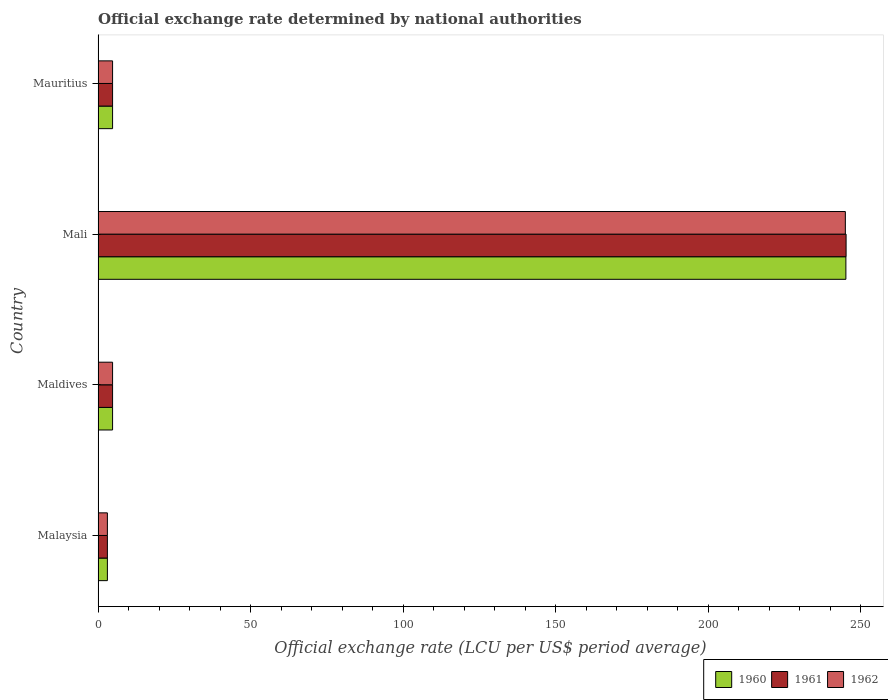How many different coloured bars are there?
Give a very brief answer. 3. How many groups of bars are there?
Keep it short and to the point. 4. Are the number of bars per tick equal to the number of legend labels?
Provide a succinct answer. Yes. How many bars are there on the 1st tick from the top?
Your answer should be very brief. 3. What is the label of the 2nd group of bars from the top?
Give a very brief answer. Mali. What is the official exchange rate in 1960 in Maldives?
Your response must be concise. 4.76. Across all countries, what is the maximum official exchange rate in 1961?
Keep it short and to the point. 245.26. Across all countries, what is the minimum official exchange rate in 1962?
Your response must be concise. 3.06. In which country was the official exchange rate in 1962 maximum?
Keep it short and to the point. Mali. In which country was the official exchange rate in 1960 minimum?
Keep it short and to the point. Malaysia. What is the total official exchange rate in 1960 in the graph?
Offer a very short reply. 257.78. What is the difference between the official exchange rate in 1961 in Mali and that in Mauritius?
Provide a succinct answer. 240.5. What is the difference between the official exchange rate in 1962 in Mauritius and the official exchange rate in 1960 in Maldives?
Your response must be concise. 0. What is the average official exchange rate in 1960 per country?
Offer a very short reply. 64.45. What is the difference between the official exchange rate in 1962 and official exchange rate in 1960 in Malaysia?
Provide a succinct answer. 0. What is the difference between the highest and the second highest official exchange rate in 1961?
Your response must be concise. 240.5. What is the difference between the highest and the lowest official exchange rate in 1962?
Give a very brief answer. 241.95. In how many countries, is the official exchange rate in 1962 greater than the average official exchange rate in 1962 taken over all countries?
Your response must be concise. 1. Is the sum of the official exchange rate in 1961 in Malaysia and Maldives greater than the maximum official exchange rate in 1960 across all countries?
Provide a succinct answer. No. What does the 3rd bar from the top in Malaysia represents?
Give a very brief answer. 1960. What does the 1st bar from the bottom in Mali represents?
Provide a succinct answer. 1960. Are all the bars in the graph horizontal?
Provide a short and direct response. Yes. Are the values on the major ticks of X-axis written in scientific E-notation?
Your answer should be very brief. No. Does the graph contain any zero values?
Offer a very short reply. No. How many legend labels are there?
Your answer should be very brief. 3. How are the legend labels stacked?
Keep it short and to the point. Horizontal. What is the title of the graph?
Offer a very short reply. Official exchange rate determined by national authorities. Does "1991" appear as one of the legend labels in the graph?
Your answer should be compact. No. What is the label or title of the X-axis?
Provide a succinct answer. Official exchange rate (LCU per US$ period average). What is the label or title of the Y-axis?
Offer a terse response. Country. What is the Official exchange rate (LCU per US$ period average) in 1960 in Malaysia?
Keep it short and to the point. 3.06. What is the Official exchange rate (LCU per US$ period average) in 1961 in Malaysia?
Your answer should be very brief. 3.06. What is the Official exchange rate (LCU per US$ period average) of 1962 in Malaysia?
Provide a short and direct response. 3.06. What is the Official exchange rate (LCU per US$ period average) of 1960 in Maldives?
Ensure brevity in your answer.  4.76. What is the Official exchange rate (LCU per US$ period average) in 1961 in Maldives?
Your answer should be compact. 4.76. What is the Official exchange rate (LCU per US$ period average) of 1962 in Maldives?
Provide a succinct answer. 4.76. What is the Official exchange rate (LCU per US$ period average) of 1960 in Mali?
Offer a terse response. 245.2. What is the Official exchange rate (LCU per US$ period average) of 1961 in Mali?
Your answer should be very brief. 245.26. What is the Official exchange rate (LCU per US$ period average) in 1962 in Mali?
Make the answer very short. 245.01. What is the Official exchange rate (LCU per US$ period average) of 1960 in Mauritius?
Your answer should be compact. 4.76. What is the Official exchange rate (LCU per US$ period average) of 1961 in Mauritius?
Provide a short and direct response. 4.76. What is the Official exchange rate (LCU per US$ period average) of 1962 in Mauritius?
Your answer should be very brief. 4.76. Across all countries, what is the maximum Official exchange rate (LCU per US$ period average) of 1960?
Your answer should be compact. 245.2. Across all countries, what is the maximum Official exchange rate (LCU per US$ period average) of 1961?
Give a very brief answer. 245.26. Across all countries, what is the maximum Official exchange rate (LCU per US$ period average) of 1962?
Give a very brief answer. 245.01. Across all countries, what is the minimum Official exchange rate (LCU per US$ period average) in 1960?
Your response must be concise. 3.06. Across all countries, what is the minimum Official exchange rate (LCU per US$ period average) of 1961?
Your response must be concise. 3.06. Across all countries, what is the minimum Official exchange rate (LCU per US$ period average) of 1962?
Keep it short and to the point. 3.06. What is the total Official exchange rate (LCU per US$ period average) of 1960 in the graph?
Provide a succinct answer. 257.78. What is the total Official exchange rate (LCU per US$ period average) of 1961 in the graph?
Your response must be concise. 257.85. What is the total Official exchange rate (LCU per US$ period average) in 1962 in the graph?
Offer a very short reply. 257.6. What is the difference between the Official exchange rate (LCU per US$ period average) in 1960 in Malaysia and that in Maldives?
Make the answer very short. -1.7. What is the difference between the Official exchange rate (LCU per US$ period average) of 1961 in Malaysia and that in Maldives?
Your answer should be compact. -1.7. What is the difference between the Official exchange rate (LCU per US$ period average) in 1962 in Malaysia and that in Maldives?
Your response must be concise. -1.7. What is the difference between the Official exchange rate (LCU per US$ period average) of 1960 in Malaysia and that in Mali?
Keep it short and to the point. -242.13. What is the difference between the Official exchange rate (LCU per US$ period average) of 1961 in Malaysia and that in Mali?
Keep it short and to the point. -242.2. What is the difference between the Official exchange rate (LCU per US$ period average) of 1962 in Malaysia and that in Mali?
Provide a succinct answer. -241.95. What is the difference between the Official exchange rate (LCU per US$ period average) of 1960 in Malaysia and that in Mauritius?
Provide a succinct answer. -1.7. What is the difference between the Official exchange rate (LCU per US$ period average) of 1961 in Malaysia and that in Mauritius?
Provide a short and direct response. -1.7. What is the difference between the Official exchange rate (LCU per US$ period average) of 1962 in Malaysia and that in Mauritius?
Make the answer very short. -1.7. What is the difference between the Official exchange rate (LCU per US$ period average) of 1960 in Maldives and that in Mali?
Ensure brevity in your answer.  -240.43. What is the difference between the Official exchange rate (LCU per US$ period average) in 1961 in Maldives and that in Mali?
Keep it short and to the point. -240.5. What is the difference between the Official exchange rate (LCU per US$ period average) in 1962 in Maldives and that in Mali?
Keep it short and to the point. -240.25. What is the difference between the Official exchange rate (LCU per US$ period average) in 1960 in Maldives and that in Mauritius?
Offer a very short reply. 0. What is the difference between the Official exchange rate (LCU per US$ period average) of 1961 in Maldives and that in Mauritius?
Make the answer very short. 0. What is the difference between the Official exchange rate (LCU per US$ period average) in 1960 in Mali and that in Mauritius?
Provide a short and direct response. 240.43. What is the difference between the Official exchange rate (LCU per US$ period average) in 1961 in Mali and that in Mauritius?
Offer a very short reply. 240.5. What is the difference between the Official exchange rate (LCU per US$ period average) of 1962 in Mali and that in Mauritius?
Ensure brevity in your answer.  240.25. What is the difference between the Official exchange rate (LCU per US$ period average) of 1960 in Malaysia and the Official exchange rate (LCU per US$ period average) of 1961 in Maldives?
Give a very brief answer. -1.7. What is the difference between the Official exchange rate (LCU per US$ period average) of 1960 in Malaysia and the Official exchange rate (LCU per US$ period average) of 1962 in Maldives?
Your answer should be very brief. -1.7. What is the difference between the Official exchange rate (LCU per US$ period average) in 1961 in Malaysia and the Official exchange rate (LCU per US$ period average) in 1962 in Maldives?
Give a very brief answer. -1.7. What is the difference between the Official exchange rate (LCU per US$ period average) in 1960 in Malaysia and the Official exchange rate (LCU per US$ period average) in 1961 in Mali?
Provide a short and direct response. -242.2. What is the difference between the Official exchange rate (LCU per US$ period average) in 1960 in Malaysia and the Official exchange rate (LCU per US$ period average) in 1962 in Mali?
Offer a very short reply. -241.95. What is the difference between the Official exchange rate (LCU per US$ period average) in 1961 in Malaysia and the Official exchange rate (LCU per US$ period average) in 1962 in Mali?
Ensure brevity in your answer.  -241.95. What is the difference between the Official exchange rate (LCU per US$ period average) in 1960 in Malaysia and the Official exchange rate (LCU per US$ period average) in 1961 in Mauritius?
Offer a terse response. -1.7. What is the difference between the Official exchange rate (LCU per US$ period average) in 1960 in Malaysia and the Official exchange rate (LCU per US$ period average) in 1962 in Mauritius?
Offer a very short reply. -1.7. What is the difference between the Official exchange rate (LCU per US$ period average) of 1961 in Malaysia and the Official exchange rate (LCU per US$ period average) of 1962 in Mauritius?
Offer a very short reply. -1.7. What is the difference between the Official exchange rate (LCU per US$ period average) of 1960 in Maldives and the Official exchange rate (LCU per US$ period average) of 1961 in Mali?
Offer a very short reply. -240.5. What is the difference between the Official exchange rate (LCU per US$ period average) of 1960 in Maldives and the Official exchange rate (LCU per US$ period average) of 1962 in Mali?
Your response must be concise. -240.25. What is the difference between the Official exchange rate (LCU per US$ period average) in 1961 in Maldives and the Official exchange rate (LCU per US$ period average) in 1962 in Mali?
Keep it short and to the point. -240.25. What is the difference between the Official exchange rate (LCU per US$ period average) of 1961 in Maldives and the Official exchange rate (LCU per US$ period average) of 1962 in Mauritius?
Your answer should be very brief. 0. What is the difference between the Official exchange rate (LCU per US$ period average) of 1960 in Mali and the Official exchange rate (LCU per US$ period average) of 1961 in Mauritius?
Offer a terse response. 240.43. What is the difference between the Official exchange rate (LCU per US$ period average) of 1960 in Mali and the Official exchange rate (LCU per US$ period average) of 1962 in Mauritius?
Your response must be concise. 240.43. What is the difference between the Official exchange rate (LCU per US$ period average) of 1961 in Mali and the Official exchange rate (LCU per US$ period average) of 1962 in Mauritius?
Make the answer very short. 240.5. What is the average Official exchange rate (LCU per US$ period average) of 1960 per country?
Make the answer very short. 64.44. What is the average Official exchange rate (LCU per US$ period average) of 1961 per country?
Provide a short and direct response. 64.46. What is the average Official exchange rate (LCU per US$ period average) of 1962 per country?
Provide a succinct answer. 64.4. What is the difference between the Official exchange rate (LCU per US$ period average) of 1960 and Official exchange rate (LCU per US$ period average) of 1962 in Malaysia?
Ensure brevity in your answer.  0. What is the difference between the Official exchange rate (LCU per US$ period average) of 1961 and Official exchange rate (LCU per US$ period average) of 1962 in Malaysia?
Offer a terse response. 0. What is the difference between the Official exchange rate (LCU per US$ period average) of 1960 and Official exchange rate (LCU per US$ period average) of 1961 in Maldives?
Provide a succinct answer. 0. What is the difference between the Official exchange rate (LCU per US$ period average) in 1961 and Official exchange rate (LCU per US$ period average) in 1962 in Maldives?
Give a very brief answer. 0. What is the difference between the Official exchange rate (LCU per US$ period average) of 1960 and Official exchange rate (LCU per US$ period average) of 1961 in Mali?
Offer a very short reply. -0.07. What is the difference between the Official exchange rate (LCU per US$ period average) of 1960 and Official exchange rate (LCU per US$ period average) of 1962 in Mali?
Your answer should be very brief. 0.18. What is the difference between the Official exchange rate (LCU per US$ period average) in 1961 and Official exchange rate (LCU per US$ period average) in 1962 in Mali?
Keep it short and to the point. 0.25. What is the difference between the Official exchange rate (LCU per US$ period average) in 1960 and Official exchange rate (LCU per US$ period average) in 1961 in Mauritius?
Provide a succinct answer. 0. What is the difference between the Official exchange rate (LCU per US$ period average) in 1960 and Official exchange rate (LCU per US$ period average) in 1962 in Mauritius?
Your response must be concise. 0. What is the difference between the Official exchange rate (LCU per US$ period average) of 1961 and Official exchange rate (LCU per US$ period average) of 1962 in Mauritius?
Ensure brevity in your answer.  0. What is the ratio of the Official exchange rate (LCU per US$ period average) of 1960 in Malaysia to that in Maldives?
Give a very brief answer. 0.64. What is the ratio of the Official exchange rate (LCU per US$ period average) in 1961 in Malaysia to that in Maldives?
Your answer should be very brief. 0.64. What is the ratio of the Official exchange rate (LCU per US$ period average) in 1962 in Malaysia to that in Maldives?
Give a very brief answer. 0.64. What is the ratio of the Official exchange rate (LCU per US$ period average) of 1960 in Malaysia to that in Mali?
Offer a very short reply. 0.01. What is the ratio of the Official exchange rate (LCU per US$ period average) in 1961 in Malaysia to that in Mali?
Provide a succinct answer. 0.01. What is the ratio of the Official exchange rate (LCU per US$ period average) of 1962 in Malaysia to that in Mali?
Provide a short and direct response. 0.01. What is the ratio of the Official exchange rate (LCU per US$ period average) in 1960 in Malaysia to that in Mauritius?
Ensure brevity in your answer.  0.64. What is the ratio of the Official exchange rate (LCU per US$ period average) of 1961 in Malaysia to that in Mauritius?
Keep it short and to the point. 0.64. What is the ratio of the Official exchange rate (LCU per US$ period average) in 1962 in Malaysia to that in Mauritius?
Your answer should be very brief. 0.64. What is the ratio of the Official exchange rate (LCU per US$ period average) of 1960 in Maldives to that in Mali?
Ensure brevity in your answer.  0.02. What is the ratio of the Official exchange rate (LCU per US$ period average) in 1961 in Maldives to that in Mali?
Provide a short and direct response. 0.02. What is the ratio of the Official exchange rate (LCU per US$ period average) in 1962 in Maldives to that in Mali?
Your answer should be very brief. 0.02. What is the ratio of the Official exchange rate (LCU per US$ period average) of 1961 in Maldives to that in Mauritius?
Ensure brevity in your answer.  1. What is the ratio of the Official exchange rate (LCU per US$ period average) in 1960 in Mali to that in Mauritius?
Your response must be concise. 51.49. What is the ratio of the Official exchange rate (LCU per US$ period average) of 1961 in Mali to that in Mauritius?
Your answer should be very brief. 51.5. What is the ratio of the Official exchange rate (LCU per US$ period average) of 1962 in Mali to that in Mauritius?
Provide a short and direct response. 51.45. What is the difference between the highest and the second highest Official exchange rate (LCU per US$ period average) in 1960?
Ensure brevity in your answer.  240.43. What is the difference between the highest and the second highest Official exchange rate (LCU per US$ period average) in 1961?
Ensure brevity in your answer.  240.5. What is the difference between the highest and the second highest Official exchange rate (LCU per US$ period average) in 1962?
Your answer should be very brief. 240.25. What is the difference between the highest and the lowest Official exchange rate (LCU per US$ period average) in 1960?
Make the answer very short. 242.13. What is the difference between the highest and the lowest Official exchange rate (LCU per US$ period average) in 1961?
Keep it short and to the point. 242.2. What is the difference between the highest and the lowest Official exchange rate (LCU per US$ period average) of 1962?
Keep it short and to the point. 241.95. 